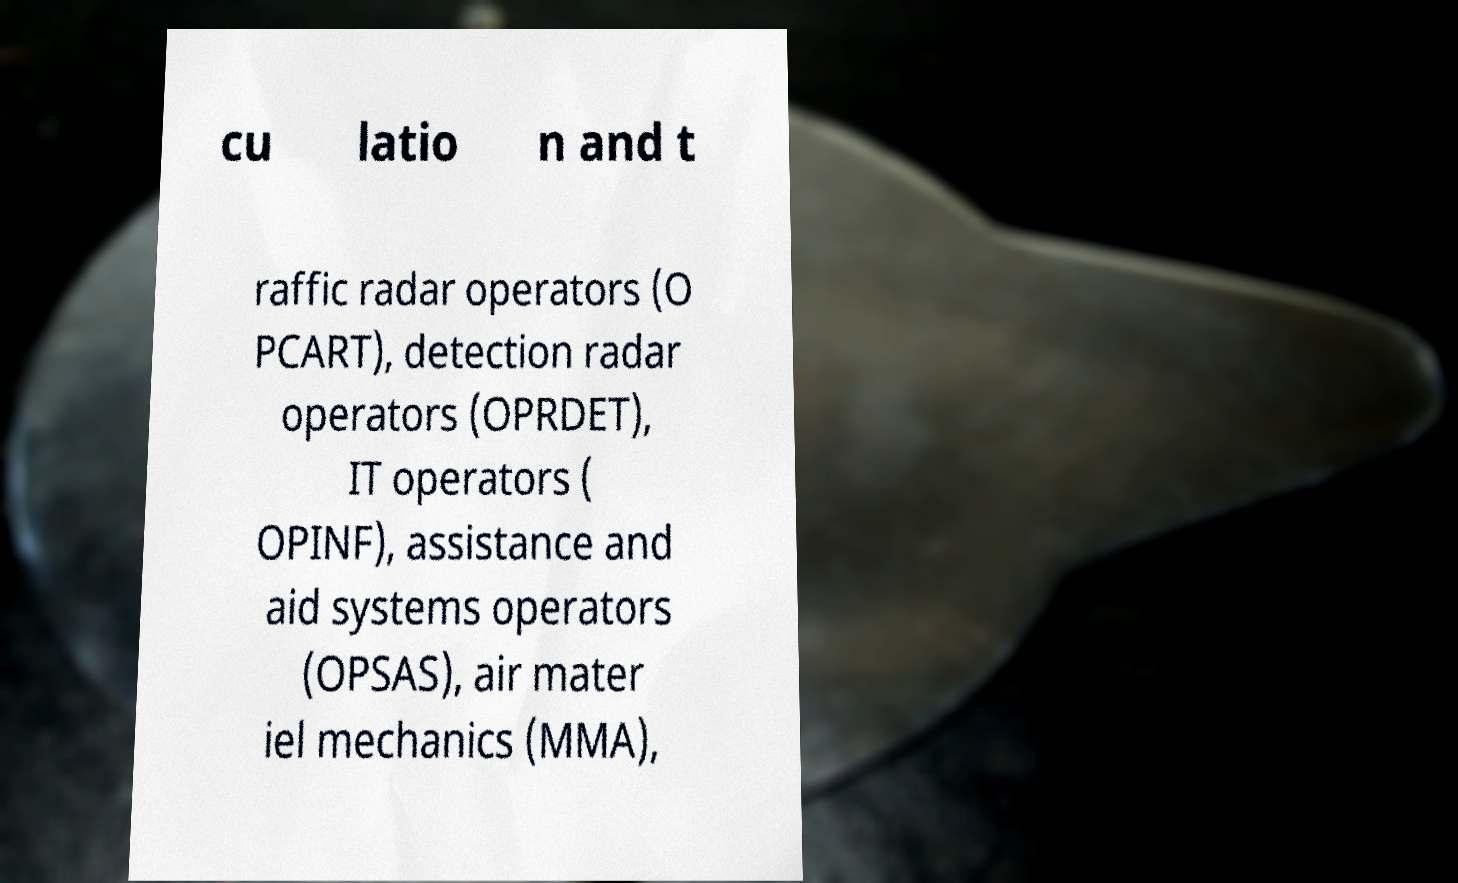I need the written content from this picture converted into text. Can you do that? cu latio n and t raffic radar operators (O PCART), detection radar operators (OPRDET), IT operators ( OPINF), assistance and aid systems operators (OPSAS), air mater iel mechanics (MMA), 